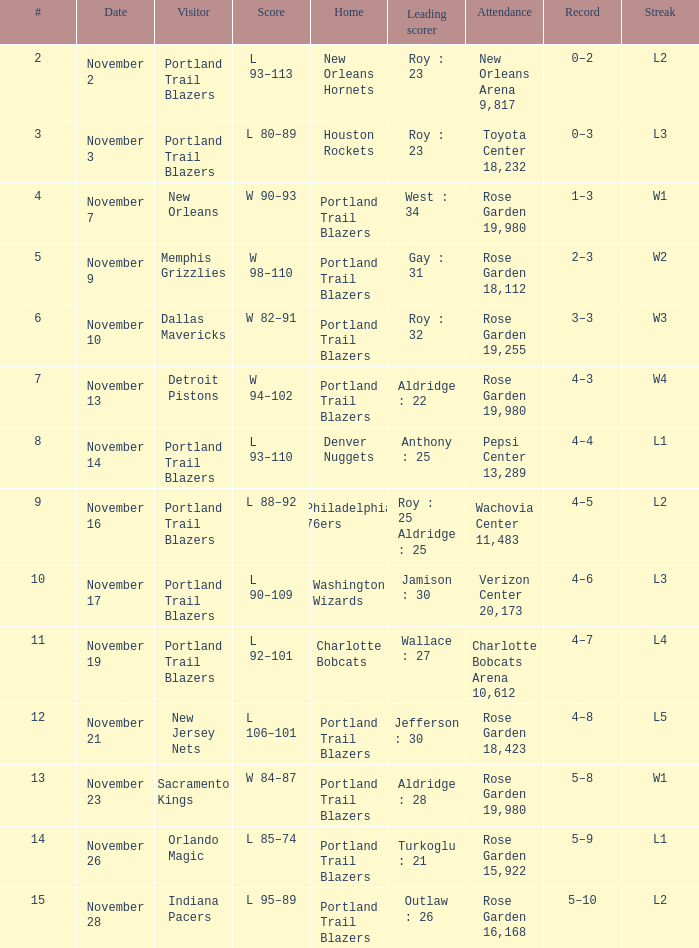What is the total number of record where streak is l2 and leading scorer is roy : 23 1.0. 